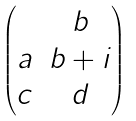Convert formula to latex. <formula><loc_0><loc_0><loc_500><loc_500>\begin{pmatrix} & b \\ a & b + i \\ c & d \end{pmatrix}</formula> 